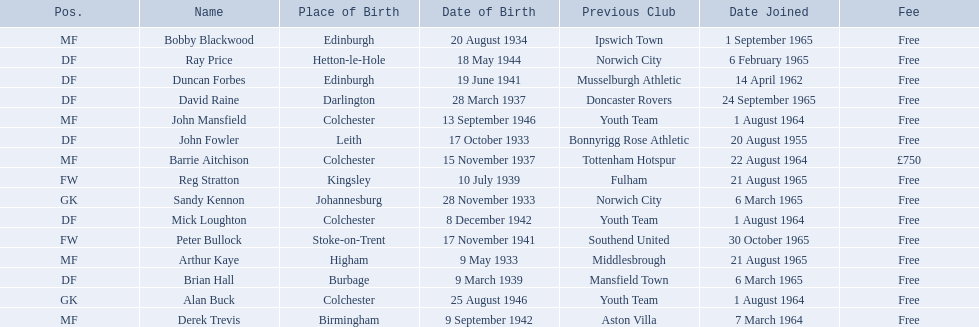Who are all the players? Alan Buck, Sandy Kennon, Duncan Forbes, John Fowler, Brian Hall, Mick Loughton, Ray Price, David Raine, Barrie Aitchison, Bobby Blackwood, Arthur Kaye, John Mansfield, Derek Trevis, Peter Bullock, Reg Stratton. What dates did the players join on? 1 August 1964, 6 March 1965, 14 April 1962, 20 August 1955, 6 March 1965, 1 August 1964, 6 February 1965, 24 September 1965, 22 August 1964, 1 September 1965, 21 August 1965, 1 August 1964, 7 March 1964, 30 October 1965, 21 August 1965. Who is the first player who joined? John Fowler. What is the date of the first person who joined? 20 August 1955. 